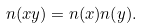<formula> <loc_0><loc_0><loc_500><loc_500>n ( x y ) = n ( x ) n ( y ) .</formula> 